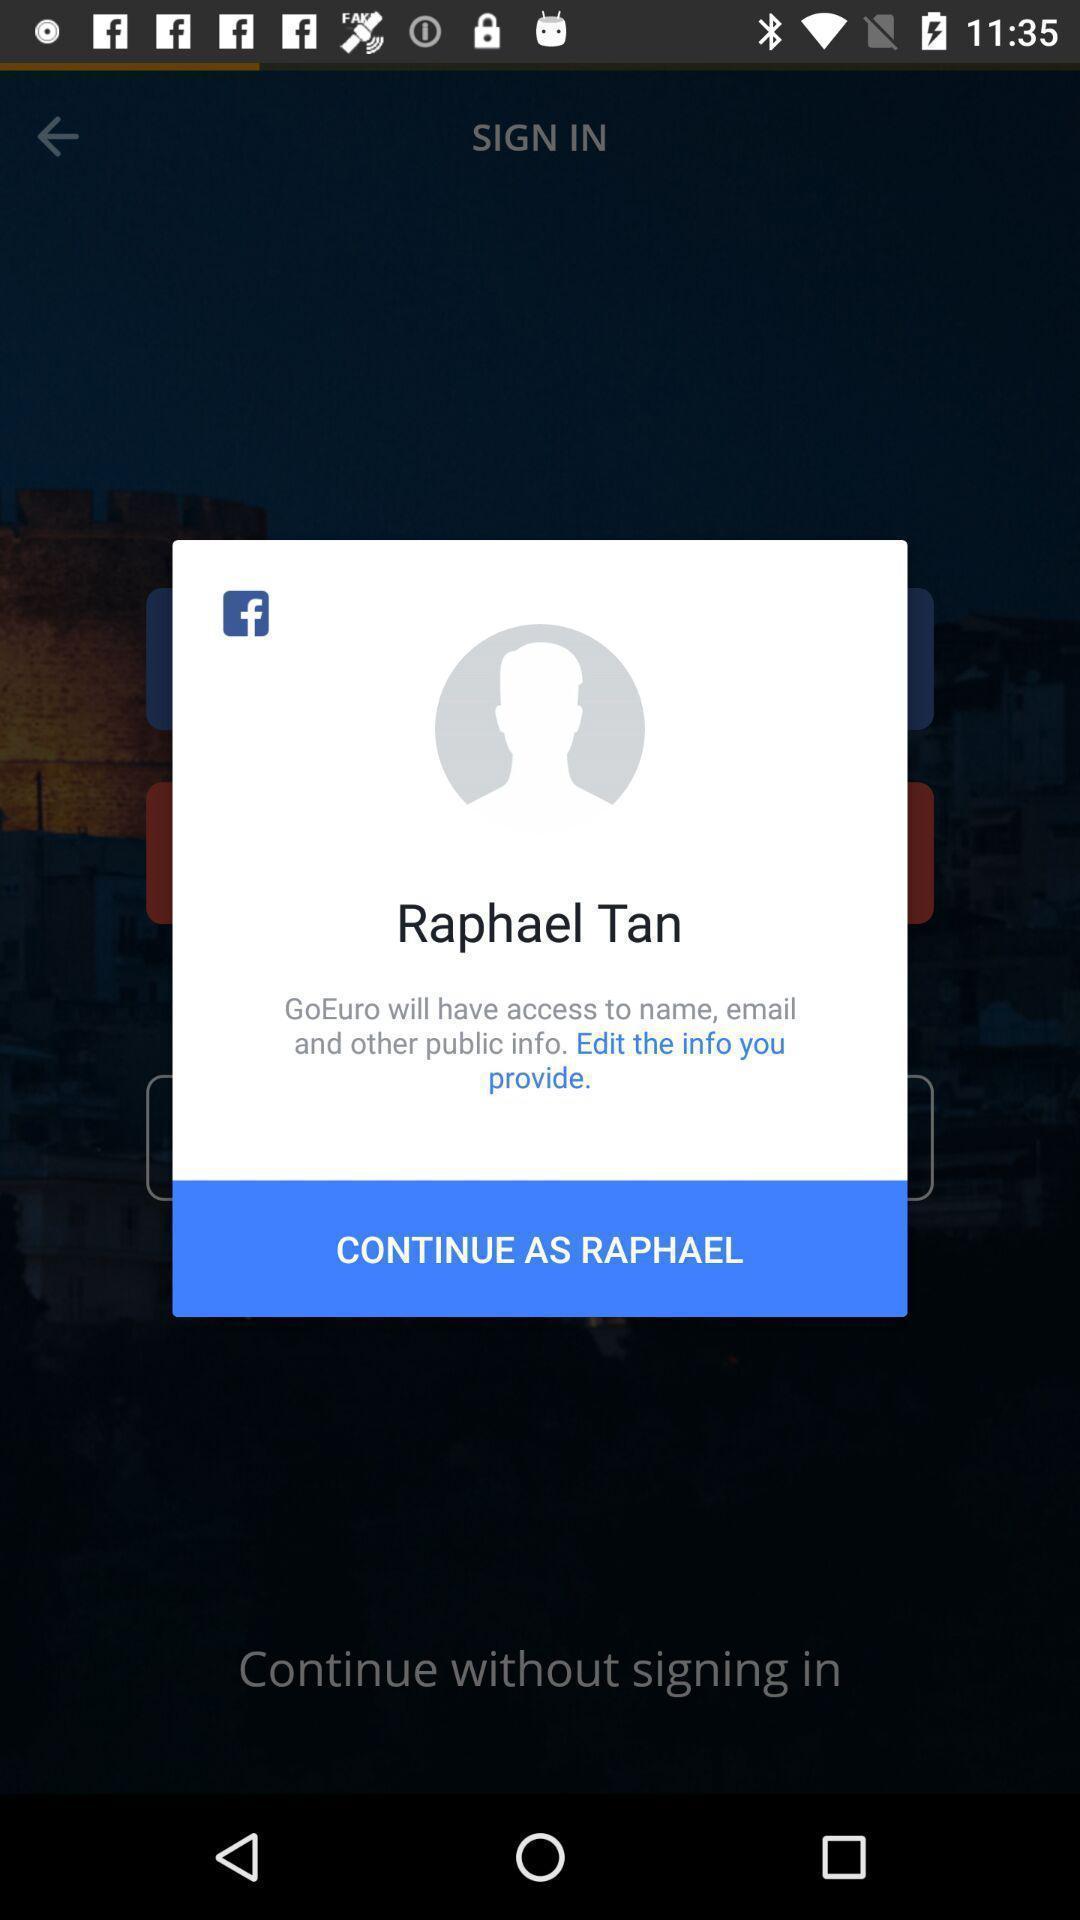Describe this image in words. Pop-up to continue as the user. 